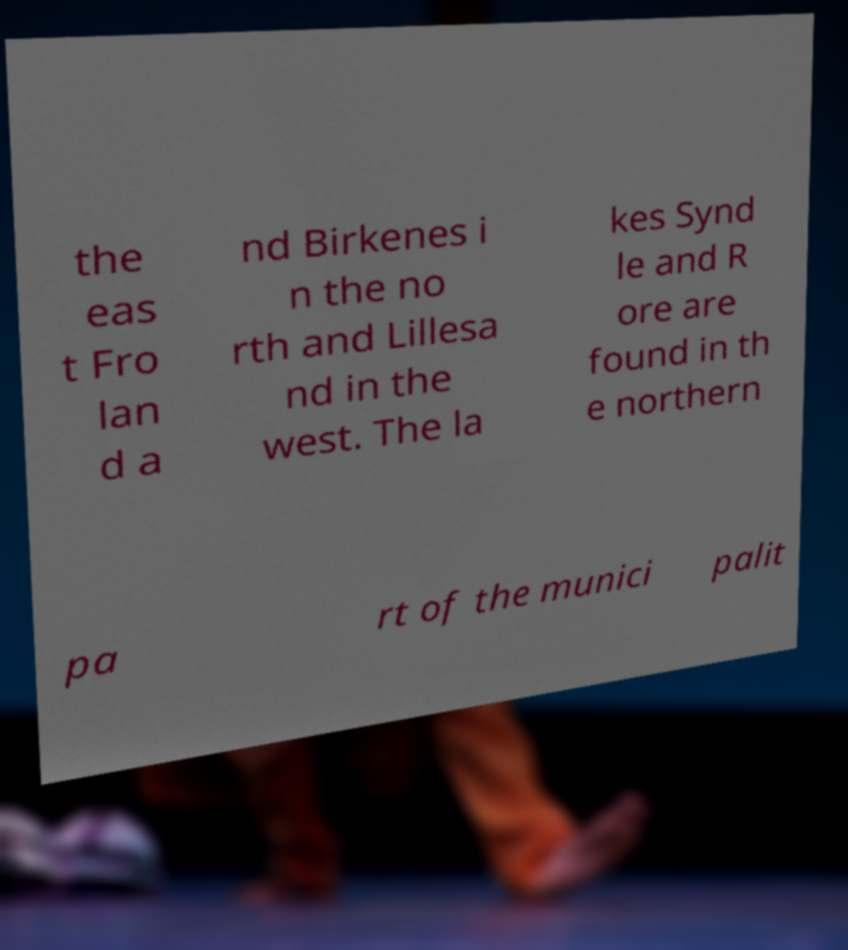Please identify and transcribe the text found in this image. the eas t Fro lan d a nd Birkenes i n the no rth and Lillesa nd in the west. The la kes Synd le and R ore are found in th e northern pa rt of the munici palit 